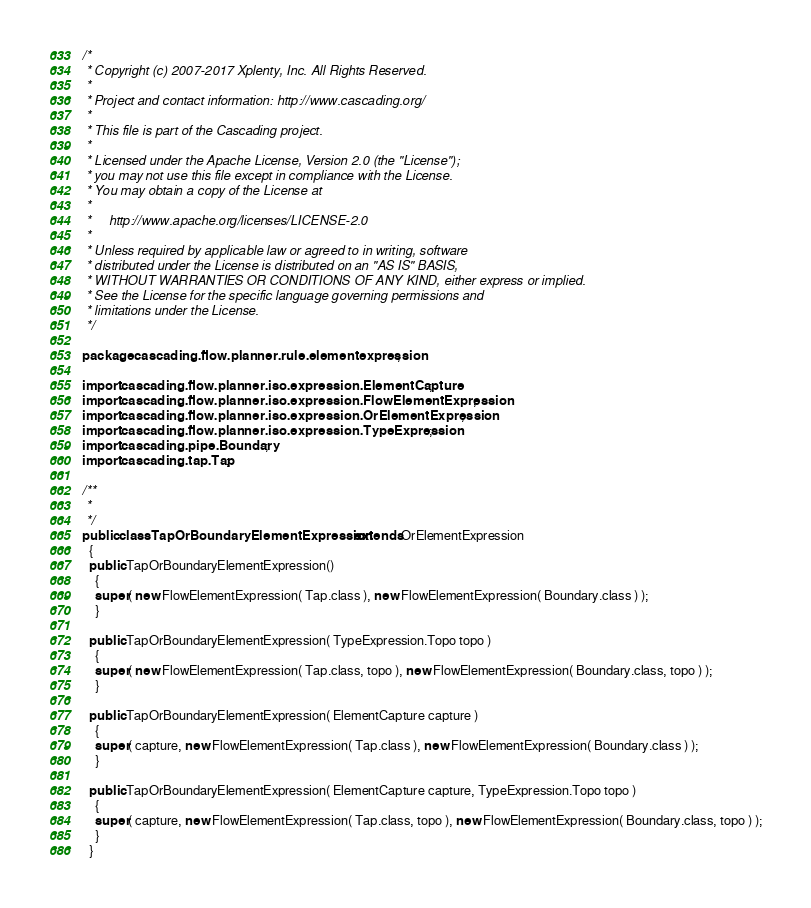<code> <loc_0><loc_0><loc_500><loc_500><_Java_>/*
 * Copyright (c) 2007-2017 Xplenty, Inc. All Rights Reserved.
 *
 * Project and contact information: http://www.cascading.org/
 *
 * This file is part of the Cascading project.
 *
 * Licensed under the Apache License, Version 2.0 (the "License");
 * you may not use this file except in compliance with the License.
 * You may obtain a copy of the License at
 *
 *     http://www.apache.org/licenses/LICENSE-2.0
 *
 * Unless required by applicable law or agreed to in writing, software
 * distributed under the License is distributed on an "AS IS" BASIS,
 * WITHOUT WARRANTIES OR CONDITIONS OF ANY KIND, either express or implied.
 * See the License for the specific language governing permissions and
 * limitations under the License.
 */

package cascading.flow.planner.rule.elementexpression;

import cascading.flow.planner.iso.expression.ElementCapture;
import cascading.flow.planner.iso.expression.FlowElementExpression;
import cascading.flow.planner.iso.expression.OrElementExpression;
import cascading.flow.planner.iso.expression.TypeExpression;
import cascading.pipe.Boundary;
import cascading.tap.Tap;

/**
 *
 */
public class TapOrBoundaryElementExpression extends OrElementExpression
  {
  public TapOrBoundaryElementExpression()
    {
    super( new FlowElementExpression( Tap.class ), new FlowElementExpression( Boundary.class ) );
    }

  public TapOrBoundaryElementExpression( TypeExpression.Topo topo )
    {
    super( new FlowElementExpression( Tap.class, topo ), new FlowElementExpression( Boundary.class, topo ) );
    }

  public TapOrBoundaryElementExpression( ElementCapture capture )
    {
    super( capture, new FlowElementExpression( Tap.class ), new FlowElementExpression( Boundary.class ) );
    }

  public TapOrBoundaryElementExpression( ElementCapture capture, TypeExpression.Topo topo )
    {
    super( capture, new FlowElementExpression( Tap.class, topo ), new FlowElementExpression( Boundary.class, topo ) );
    }
  }
</code> 